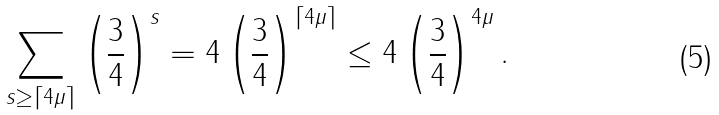Convert formula to latex. <formula><loc_0><loc_0><loc_500><loc_500>\sum _ { s \geq \lceil 4 \mu \rceil } \left ( \frac { 3 } { 4 } \right ) ^ { s } = 4 \left ( \frac { 3 } { 4 } \right ) ^ { \lceil 4 \mu \rceil } \leq 4 \left ( \frac { 3 } { 4 } \right ) ^ { 4 \mu } .</formula> 